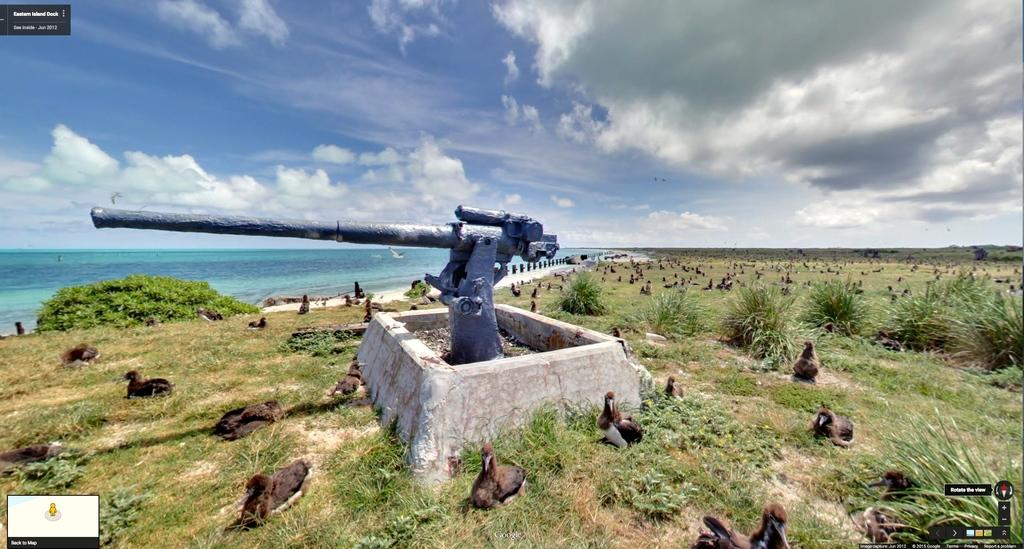What is the condition of the sky in the image? The sky is cloudy in the image. What type of object can be seen in the image? There is a military weapon in the image. What type of living organisms can be seen in the image? Birds are visible in the image. What type of vegetation is present in the image? Grass and plants are visible in the image. What is the nature of the water in the image? The presence of water is mentioned, but its specific nature is not described in the facts. Can you tell me how many tigers are bathing in the water in the image? There are no tigers or bathing activity present in the image. 